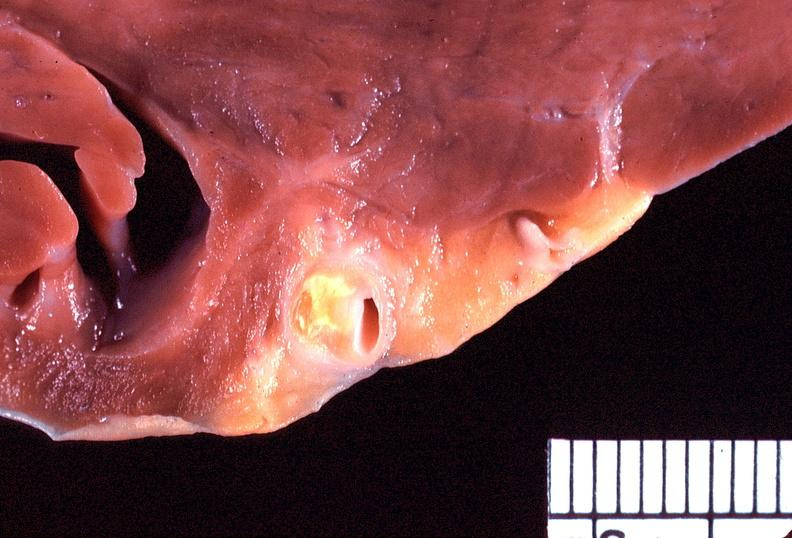does lesion of myocytolysis show heart, coronary artery, atherosclerosis?
Answer the question using a single word or phrase. No 